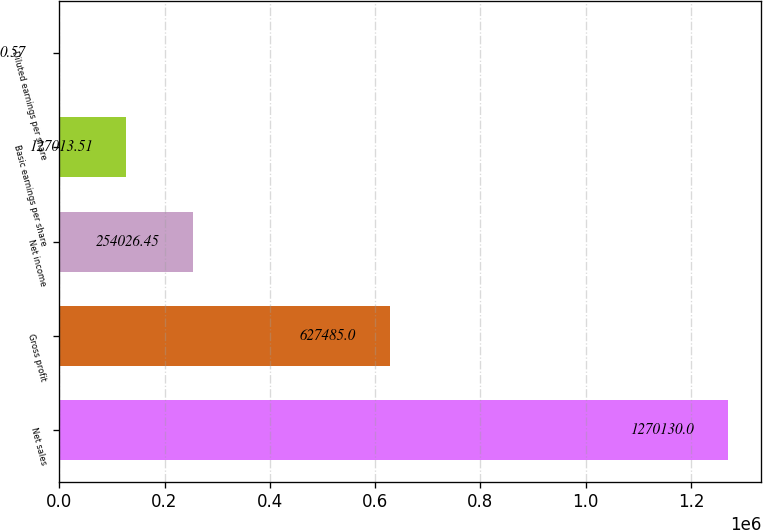Convert chart. <chart><loc_0><loc_0><loc_500><loc_500><bar_chart><fcel>Net sales<fcel>Gross profit<fcel>Net income<fcel>Basic earnings per share<fcel>Diluted earnings per share<nl><fcel>1.27013e+06<fcel>627485<fcel>254026<fcel>127014<fcel>0.57<nl></chart> 